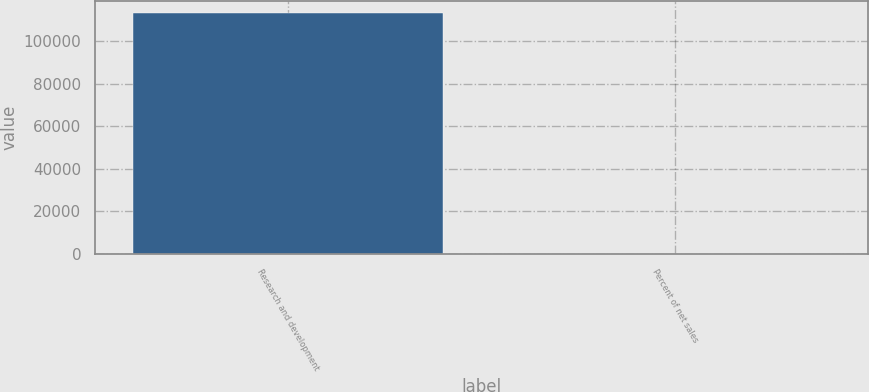<chart> <loc_0><loc_0><loc_500><loc_500><bar_chart><fcel>Research and development<fcel>Percent of net sales<nl><fcel>113314<fcel>6.4<nl></chart> 